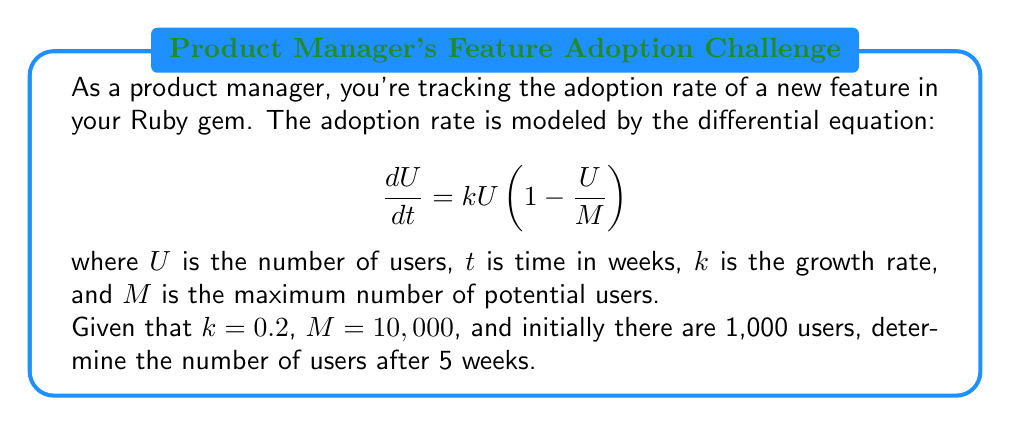Give your solution to this math problem. To solve this problem, we need to use the logistic growth model, which is a first-order differential equation. Let's approach this step-by-step:

1) The given differential equation is:
   $$\frac{dU}{dt} = kU(1 - \frac{U}{M})$$

2) This is a separable equation. We can solve it by separating variables and integrating:
   $$\int \frac{dU}{U(1-\frac{U}{M})} = \int k dt$$

3) The left side can be decomposed using partial fractions:
   $$\int (\frac{1}{U} + \frac{1}{M-U}) dU = kt + C$$

4) Integrating both sides:
   $$\ln|U| - \ln|M-U| = kt + C$$

5) Simplifying and applying the exponential function to both sides:
   $$\frac{U}{M-U} = Ae^{kt}$$, where $A = e^C$

6) Solving for $U$:
   $$U = \frac{MAe^{kt}}{1 + Ae^{kt}}$$

7) Using the initial condition $U(0) = 1000$, we can find $A$:
   $$1000 = \frac{10000A}{1+A}$$
   $$A = \frac{1000}{9000} = \frac{1}{9}$$

8) Now our solution is:
   $$U = \frac{10000(\frac{1}{9})e^{0.2t}}{1 + (\frac{1}{9})e^{0.2t}}$$

9) To find $U$ after 5 weeks, we substitute $t = 5$:
   $$U(5) = \frac{10000(\frac{1}{9})e^{1}}{1 + (\frac{1}{9})e^{1}} \approx 2689.8$$

Therefore, after 5 weeks, there will be approximately 2,690 users.
Answer: 2,690 users 